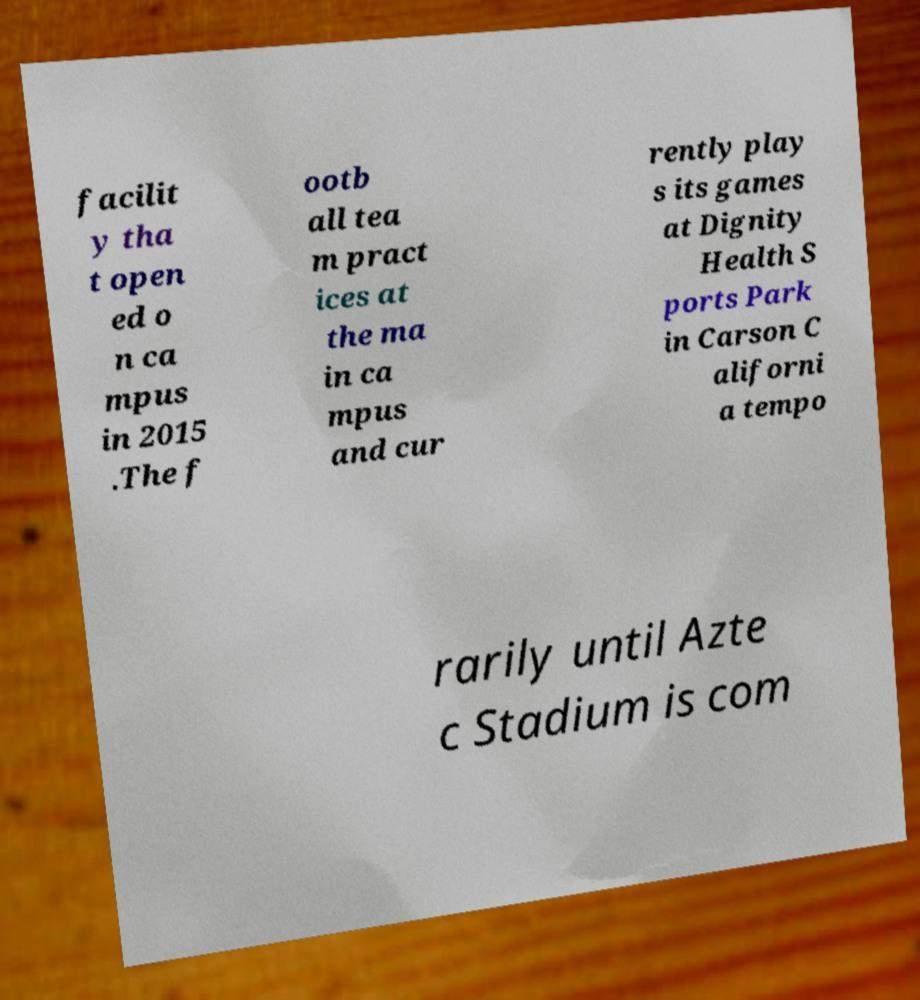Please identify and transcribe the text found in this image. facilit y tha t open ed o n ca mpus in 2015 .The f ootb all tea m pract ices at the ma in ca mpus and cur rently play s its games at Dignity Health S ports Park in Carson C aliforni a tempo rarily until Azte c Stadium is com 